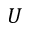<formula> <loc_0><loc_0><loc_500><loc_500>U</formula> 